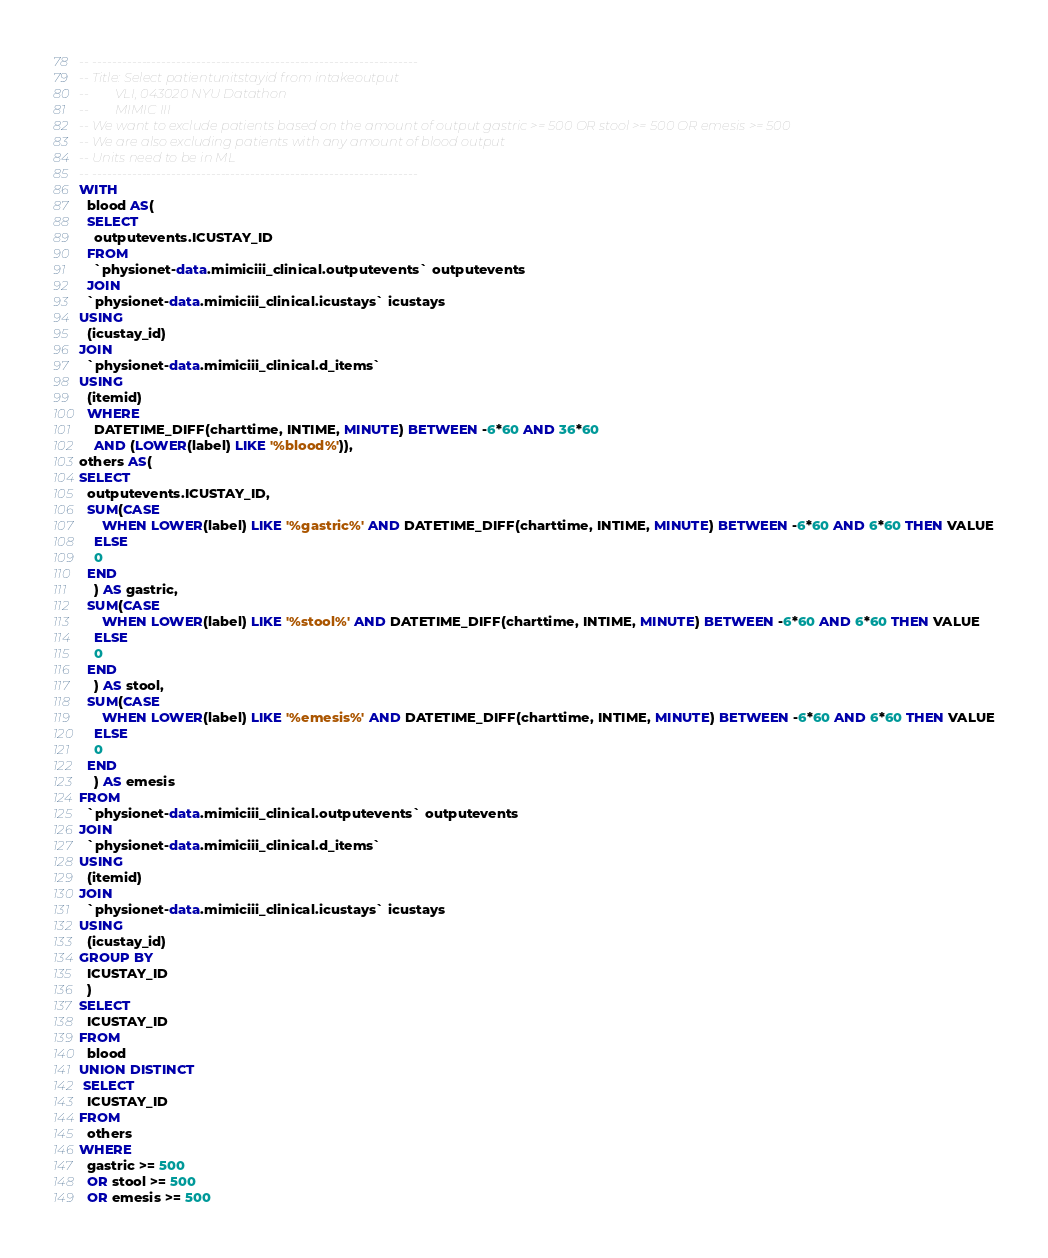<code> <loc_0><loc_0><loc_500><loc_500><_SQL_>-- ------------------------------------------------------------------
-- Title: Select patientunitstayid from intakeoutput 
--        VLI, 043020 NYU Datathon
--        MIMIC III
-- We want to exclude patients based on the amount of output gastric >= 500 OR stool >= 500 OR emesis >= 500
-- We are also excluding patients with any amount of blood output
-- Units need to be in ML
-- ------------------------------------------------------------------
WITH 
  blood AS(
  SELECT
    outputevents.ICUSTAY_ID
  FROM
    `physionet-data.mimiciii_clinical.outputevents` outputevents
  JOIN
  `physionet-data.mimiciii_clinical.icustays` icustays
USING
  (icustay_id)  
JOIN
  `physionet-data.mimiciii_clinical.d_items`
USING
  (itemid)  
  WHERE
    DATETIME_DIFF(charttime, INTIME, MINUTE) BETWEEN -6*60 AND 36*60 
    AND (LOWER(label) LIKE '%blood%')),
others AS(
SELECT
  outputevents.ICUSTAY_ID,
  SUM(CASE
      WHEN LOWER(label) LIKE '%gastric%' AND DATETIME_DIFF(charttime, INTIME, MINUTE) BETWEEN -6*60 AND 6*60 THEN VALUE
    ELSE
    0
  END
    ) AS gastric,
  SUM(CASE
      WHEN LOWER(label) LIKE '%stool%' AND DATETIME_DIFF(charttime, INTIME, MINUTE) BETWEEN -6*60 AND 6*60 THEN VALUE
    ELSE
    0
  END
    ) AS stool,
  SUM(CASE
      WHEN LOWER(label) LIKE '%emesis%' AND DATETIME_DIFF(charttime, INTIME, MINUTE) BETWEEN -6*60 AND 6*60 THEN VALUE
    ELSE
    0
  END
    ) AS emesis
FROM
  `physionet-data.mimiciii_clinical.outputevents` outputevents
JOIN
  `physionet-data.mimiciii_clinical.d_items`
USING
  (itemid)
JOIN
  `physionet-data.mimiciii_clinical.icustays` icustays
USING
  (icustay_id)
GROUP BY
  ICUSTAY_ID
  )
SELECT
  ICUSTAY_ID
FROM
  blood
UNION DISTINCT  
 SELECT
  ICUSTAY_ID
FROM
  others
WHERE
  gastric >= 500
  OR stool >= 500
  OR emesis >= 500 </code> 